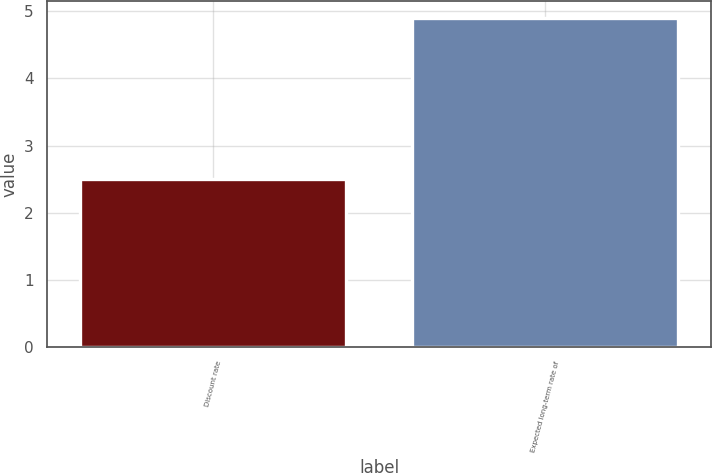<chart> <loc_0><loc_0><loc_500><loc_500><bar_chart><fcel>Discount rate<fcel>Expected long-term rate of<nl><fcel>2.5<fcel>4.9<nl></chart> 